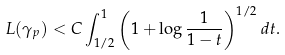<formula> <loc_0><loc_0><loc_500><loc_500>L ( \gamma _ { p } ) < C \int _ { 1 / 2 } ^ { 1 } \left ( 1 + \log \frac { 1 } { 1 - t } \right ) ^ { 1 / 2 } d t .</formula> 